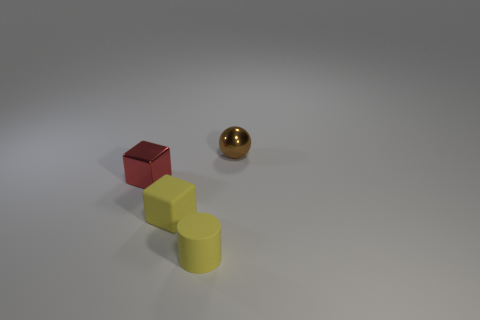Are there any other things that have the same shape as the brown object?
Offer a terse response. No. There is a small cylinder that is made of the same material as the yellow cube; what color is it?
Your answer should be very brief. Yellow. There is a small thing that is in front of the block in front of the tiny metal object in front of the small brown metallic thing; what is its material?
Offer a very short reply. Rubber. There is a metallic object that is on the left side of the brown metal object; does it have the same size as the yellow cylinder?
Ensure brevity in your answer.  Yes. What number of large objects are cyan things or yellow cylinders?
Ensure brevity in your answer.  0. Are there any tiny rubber things of the same color as the tiny matte cube?
Your answer should be compact. Yes. What shape is the yellow matte thing that is the same size as the yellow cylinder?
Your answer should be very brief. Cube. There is a small block on the right side of the red thing; does it have the same color as the tiny cylinder?
Make the answer very short. Yes. What number of objects are either brown shiny balls that are behind the red thing or brown metal balls?
Offer a very short reply. 1. Is the number of red shiny things that are left of the ball greater than the number of small red shiny things that are left of the red metallic block?
Keep it short and to the point. Yes. 